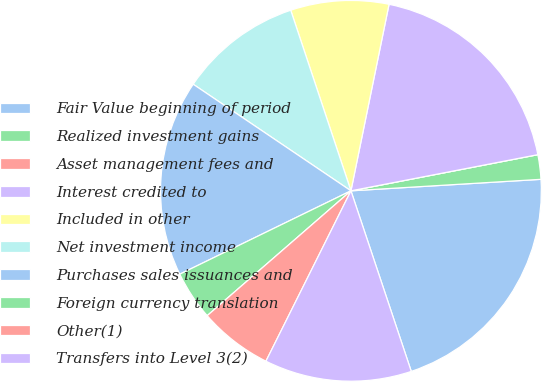<chart> <loc_0><loc_0><loc_500><loc_500><pie_chart><fcel>Fair Value beginning of period<fcel>Realized investment gains<fcel>Asset management fees and<fcel>Interest credited to<fcel>Included in other<fcel>Net investment income<fcel>Purchases sales issuances and<fcel>Foreign currency translation<fcel>Other(1)<fcel>Transfers into Level 3(2)<nl><fcel>20.83%<fcel>2.08%<fcel>0.0%<fcel>18.75%<fcel>8.33%<fcel>10.42%<fcel>16.67%<fcel>4.17%<fcel>6.25%<fcel>12.5%<nl></chart> 